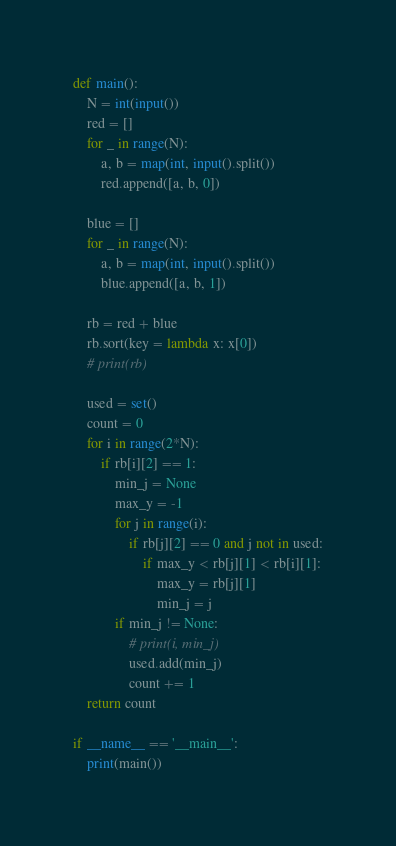<code> <loc_0><loc_0><loc_500><loc_500><_Python_>def main():
    N = int(input())
    red = []
    for _ in range(N):
        a, b = map(int, input().split())
        red.append([a, b, 0])

    blue = []
    for _ in range(N):
        a, b = map(int, input().split())
        blue.append([a, b, 1])

    rb = red + blue
    rb.sort(key = lambda x: x[0])
    # print(rb)

    used = set()
    count = 0
    for i in range(2*N):
        if rb[i][2] == 1:
            min_j = None
            max_y = -1
            for j in range(i):
                if rb[j][2] == 0 and j not in used:
                    if max_y < rb[j][1] < rb[i][1]:
                        max_y = rb[j][1]
                        min_j = j
            if min_j != None:
                # print(i, min_j)
                used.add(min_j)
                count += 1
    return count

if __name__ == '__main__':
    print(main())</code> 